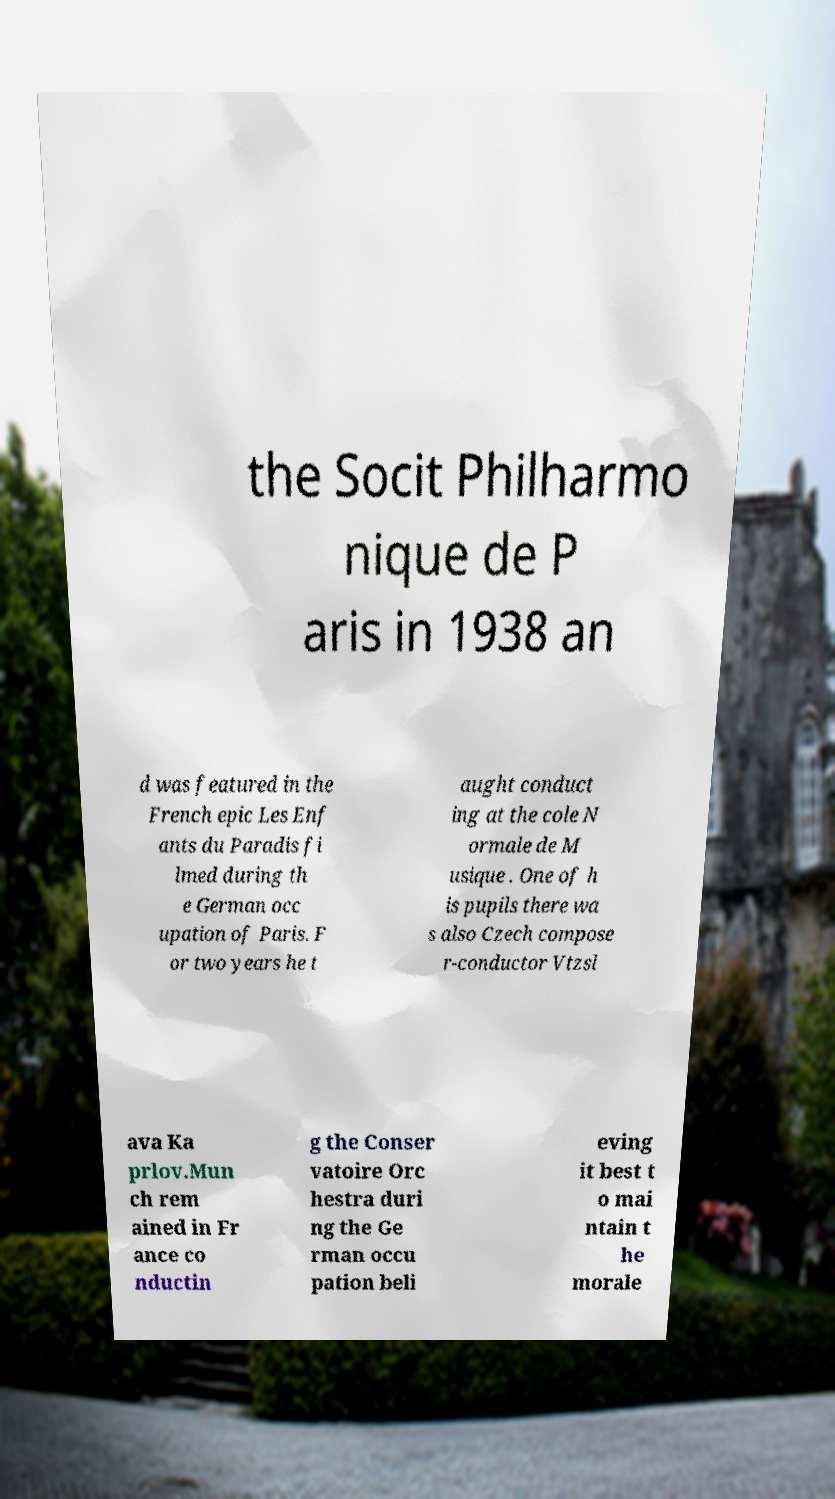Can you accurately transcribe the text from the provided image for me? the Socit Philharmo nique de P aris in 1938 an d was featured in the French epic Les Enf ants du Paradis fi lmed during th e German occ upation of Paris. F or two years he t aught conduct ing at the cole N ormale de M usique . One of h is pupils there wa s also Czech compose r-conductor Vtzsl ava Ka prlov.Mun ch rem ained in Fr ance co nductin g the Conser vatoire Orc hestra duri ng the Ge rman occu pation beli eving it best t o mai ntain t he morale 